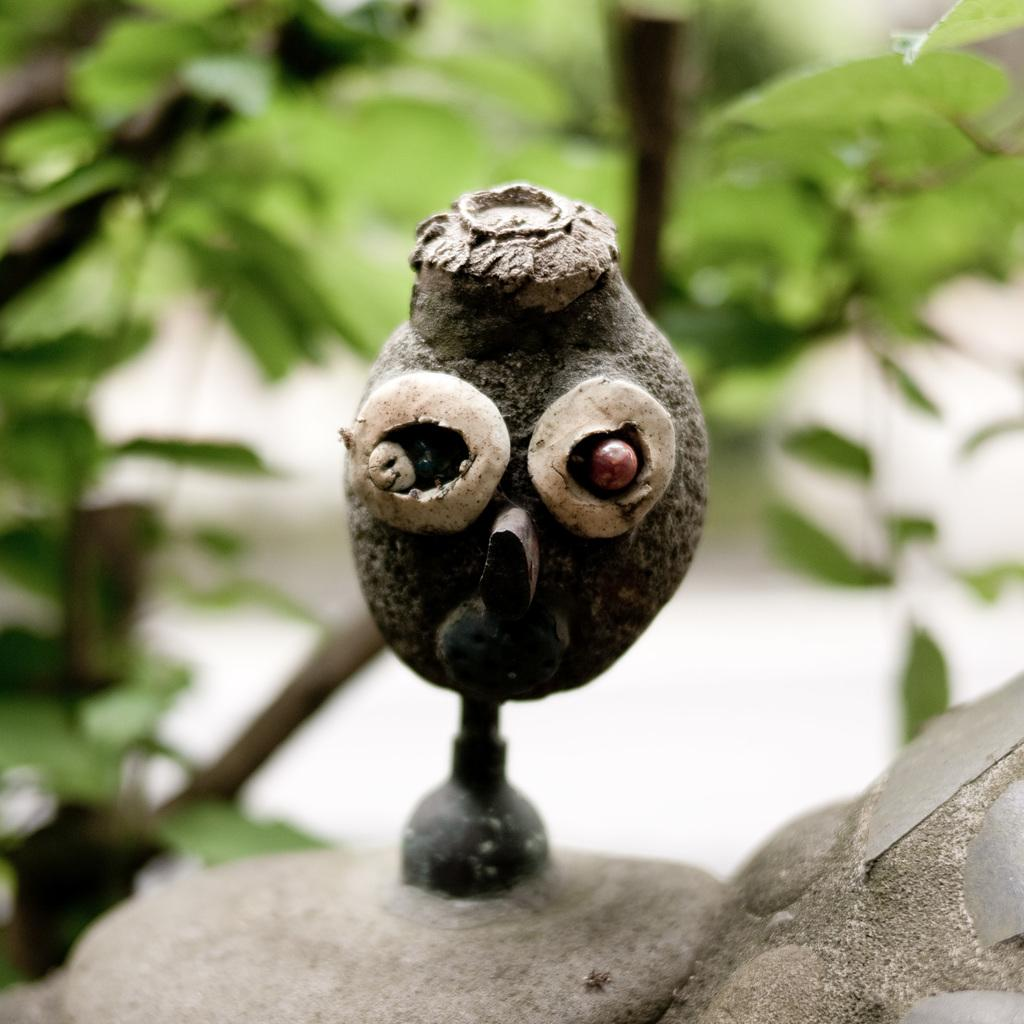What is the main subject in the middle of the image? There is an object in the middle of the image. What type of vegetation can be seen in the image? There are green leaves in the image. Is anyone wearing a mask in the image? There is no information about masks or people in the image, as it only mentions an object and green leaves. 